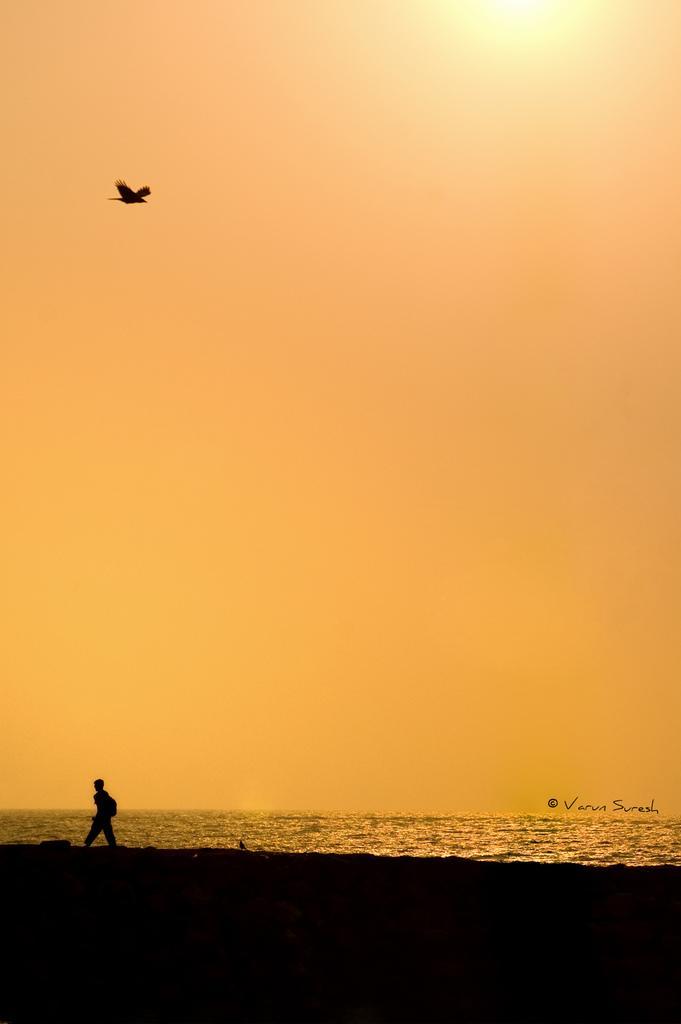Please provide a concise description of this image. In the picture we can see a person standing, there is water and top of the picture there is a bird which is flying and there is yellow color sky. 